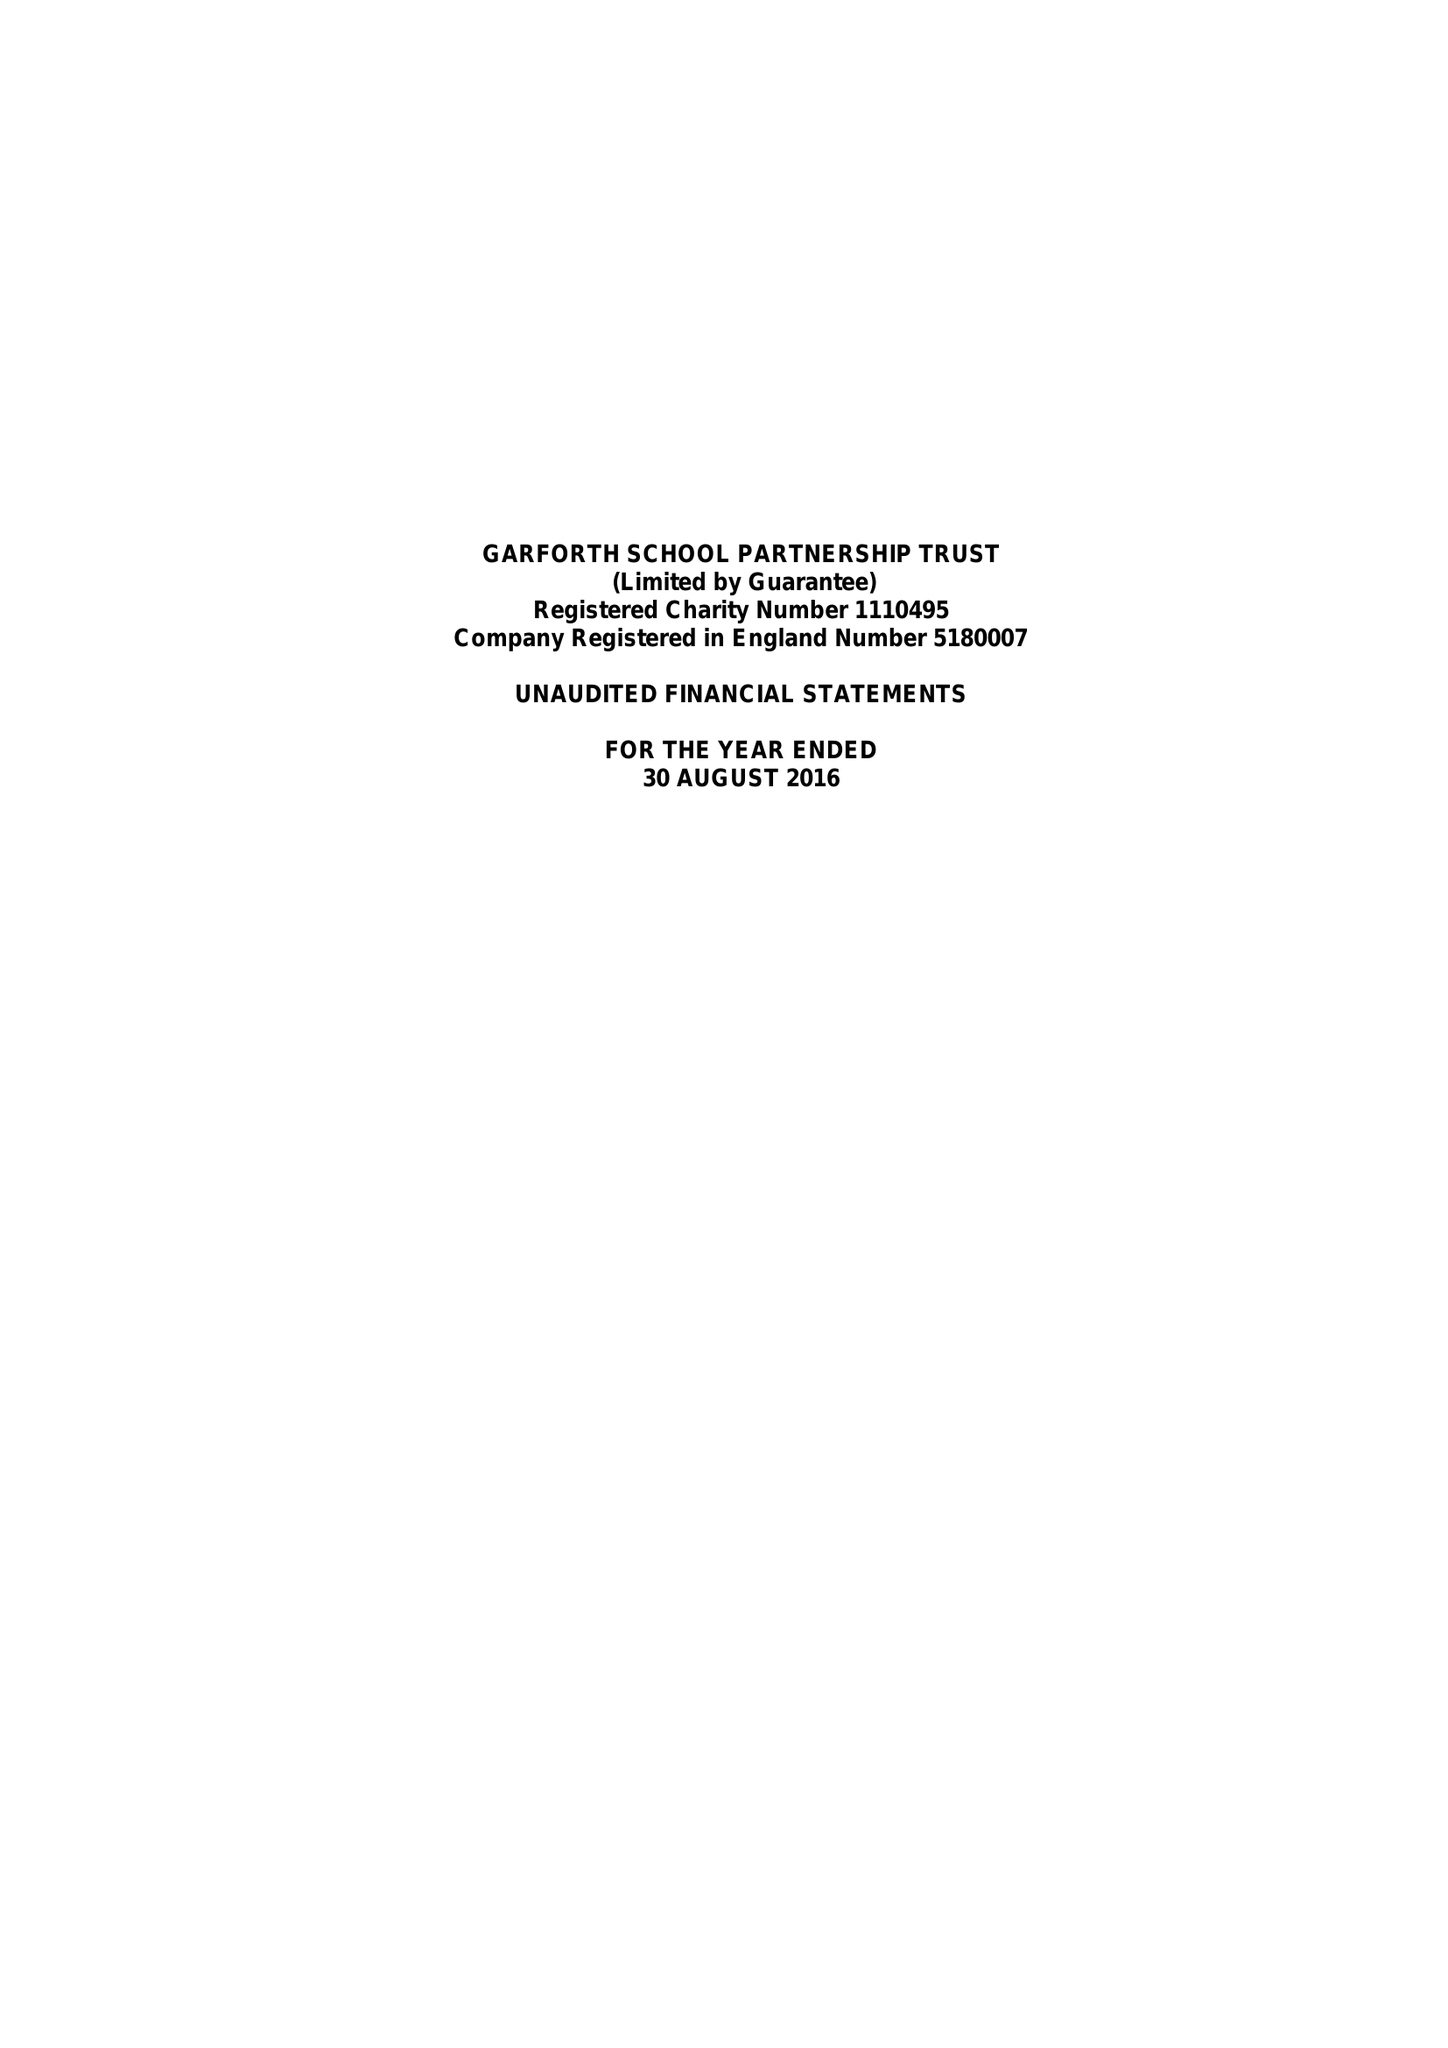What is the value for the spending_annually_in_british_pounds?
Answer the question using a single word or phrase. 89059.00 